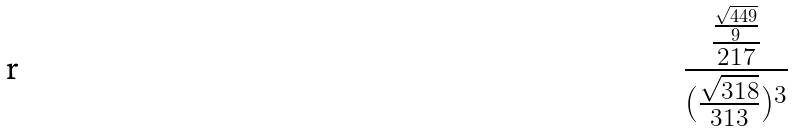Convert formula to latex. <formula><loc_0><loc_0><loc_500><loc_500>\frac { \frac { \frac { \sqrt { 4 4 9 } } { 9 } } { 2 1 7 } } { ( \frac { \sqrt { 3 1 8 } } { 3 1 3 } ) ^ { 3 } }</formula> 